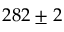<formula> <loc_0><loc_0><loc_500><loc_500>2 8 2 \pm 2</formula> 